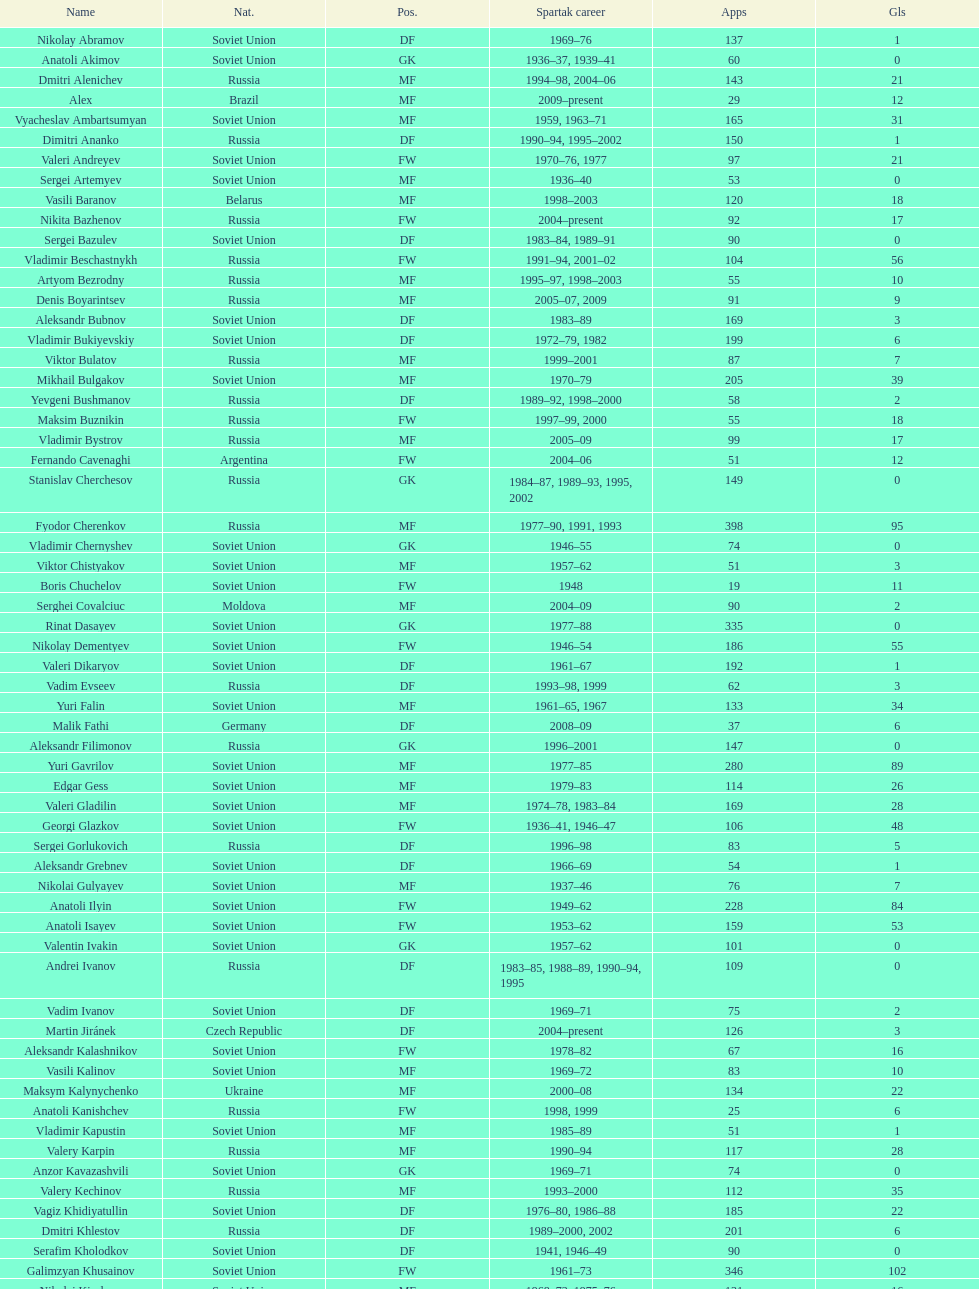Vladimir bukiyevskiy had how many appearances? 199. 